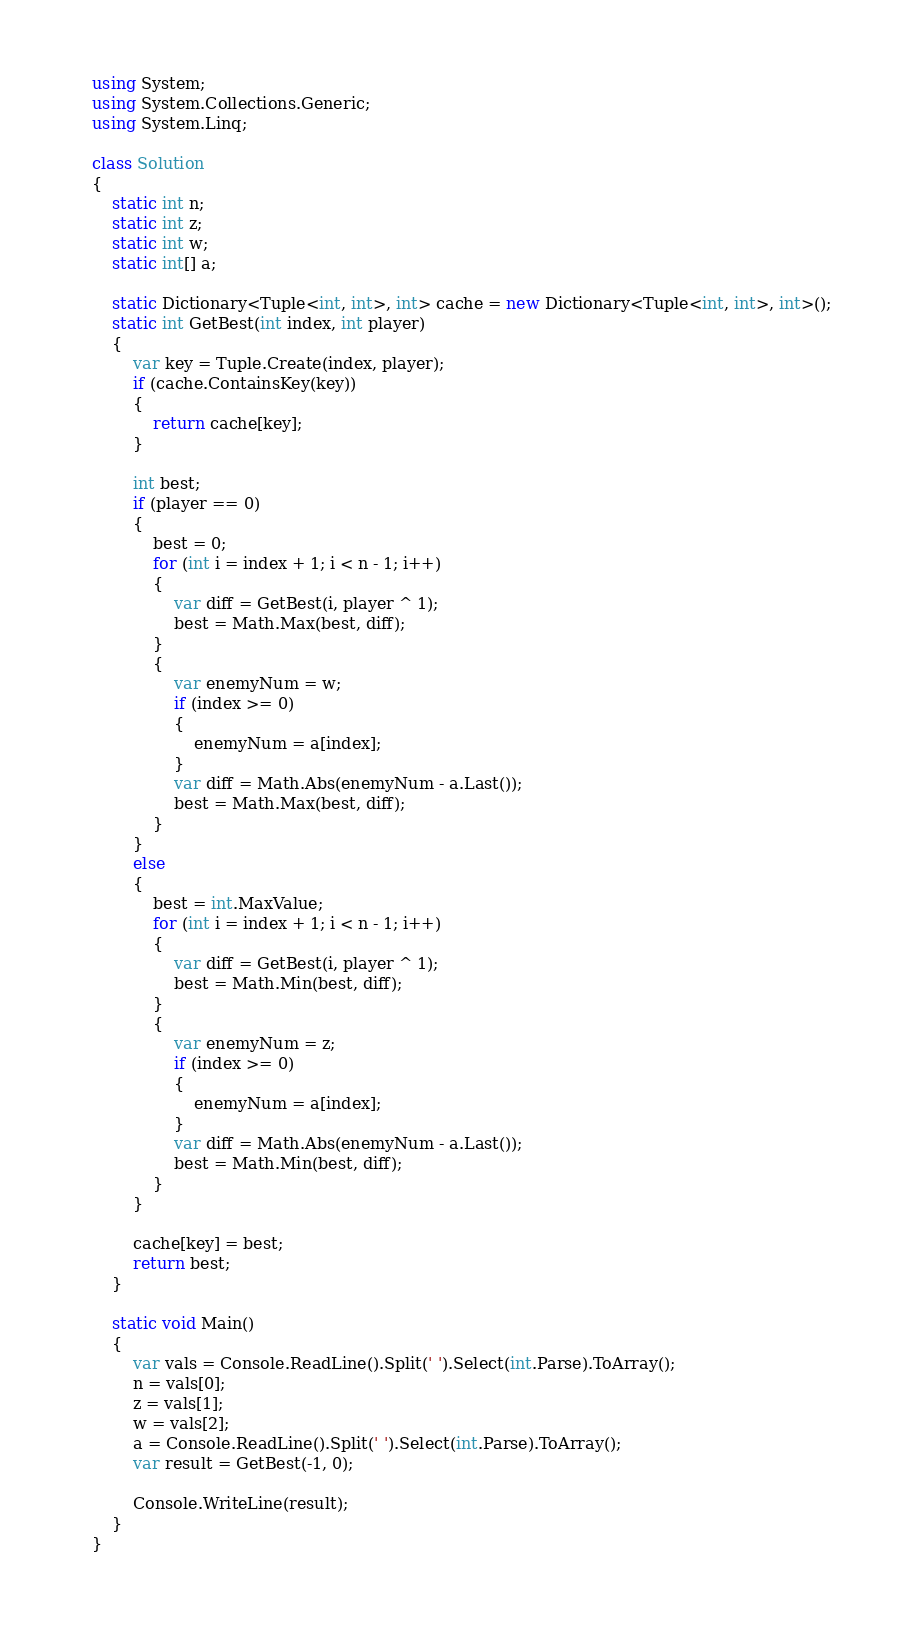<code> <loc_0><loc_0><loc_500><loc_500><_C#_>using System;
using System.Collections.Generic;
using System.Linq;

class Solution
{
    static int n;
    static int z;
    static int w;
    static int[] a;

    static Dictionary<Tuple<int, int>, int> cache = new Dictionary<Tuple<int, int>, int>();
    static int GetBest(int index, int player)
    {
        var key = Tuple.Create(index, player);
        if (cache.ContainsKey(key))
        {
            return cache[key];
        }

        int best;
        if (player == 0)
        {
            best = 0;
            for (int i = index + 1; i < n - 1; i++)
            {
                var diff = GetBest(i, player ^ 1);
                best = Math.Max(best, diff);
            }
            {
                var enemyNum = w;
                if (index >= 0)
                {
                    enemyNum = a[index];
                }
                var diff = Math.Abs(enemyNum - a.Last());
                best = Math.Max(best, diff);
            }
        }
        else
        {
            best = int.MaxValue;
            for (int i = index + 1; i < n - 1; i++)
            {
                var diff = GetBest(i, player ^ 1);
                best = Math.Min(best, diff);
            }
            {
                var enemyNum = z;
                if (index >= 0)
                {
                    enemyNum = a[index];
                }
                var diff = Math.Abs(enemyNum - a.Last());
                best = Math.Min(best, diff);
            }
        }

        cache[key] = best;
        return best;
    }

    static void Main()
    {
        var vals = Console.ReadLine().Split(' ').Select(int.Parse).ToArray();
        n = vals[0];
        z = vals[1];
        w = vals[2];
        a = Console.ReadLine().Split(' ').Select(int.Parse).ToArray();
        var result = GetBest(-1, 0);
        
        Console.WriteLine(result);
    }
}</code> 